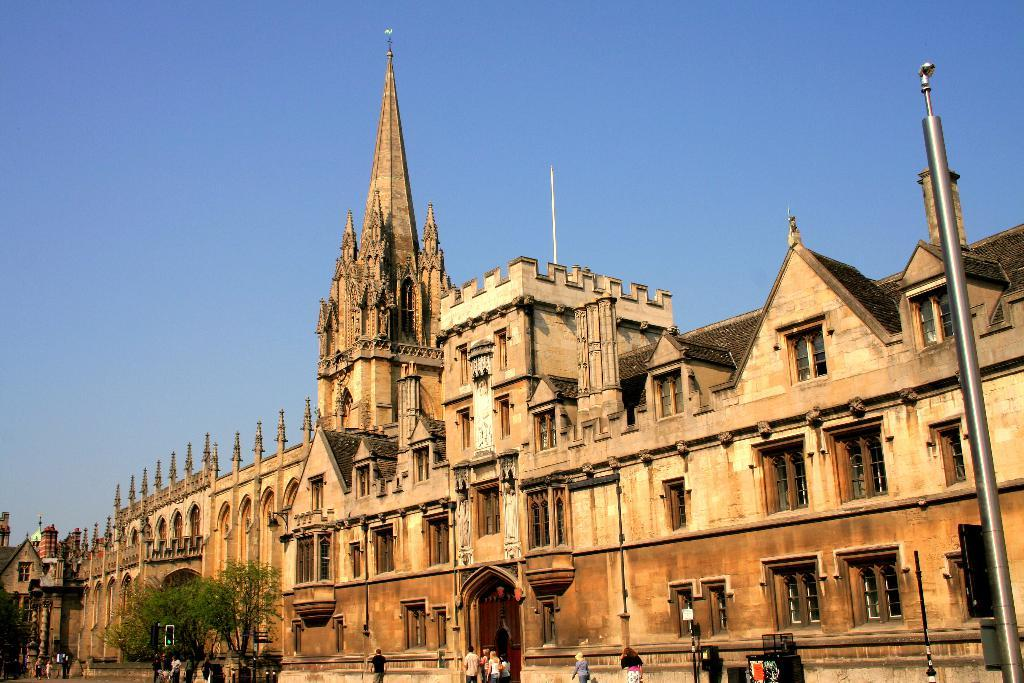What structure is the main focus of the image? There is a building in the image. What is located in front of the building? There are poles and trees in front of the building. What is happening at the bottom of the image? People are walking on the road at the bottom of the image. What can be seen at the top of the image? The sky is visible at the top of the image. What type of ornament is hanging from the building in the image? There is no ornament hanging from the building in the image. What nation is represented by the flag on the building in the image? There is no flag visible on the building in the image. 